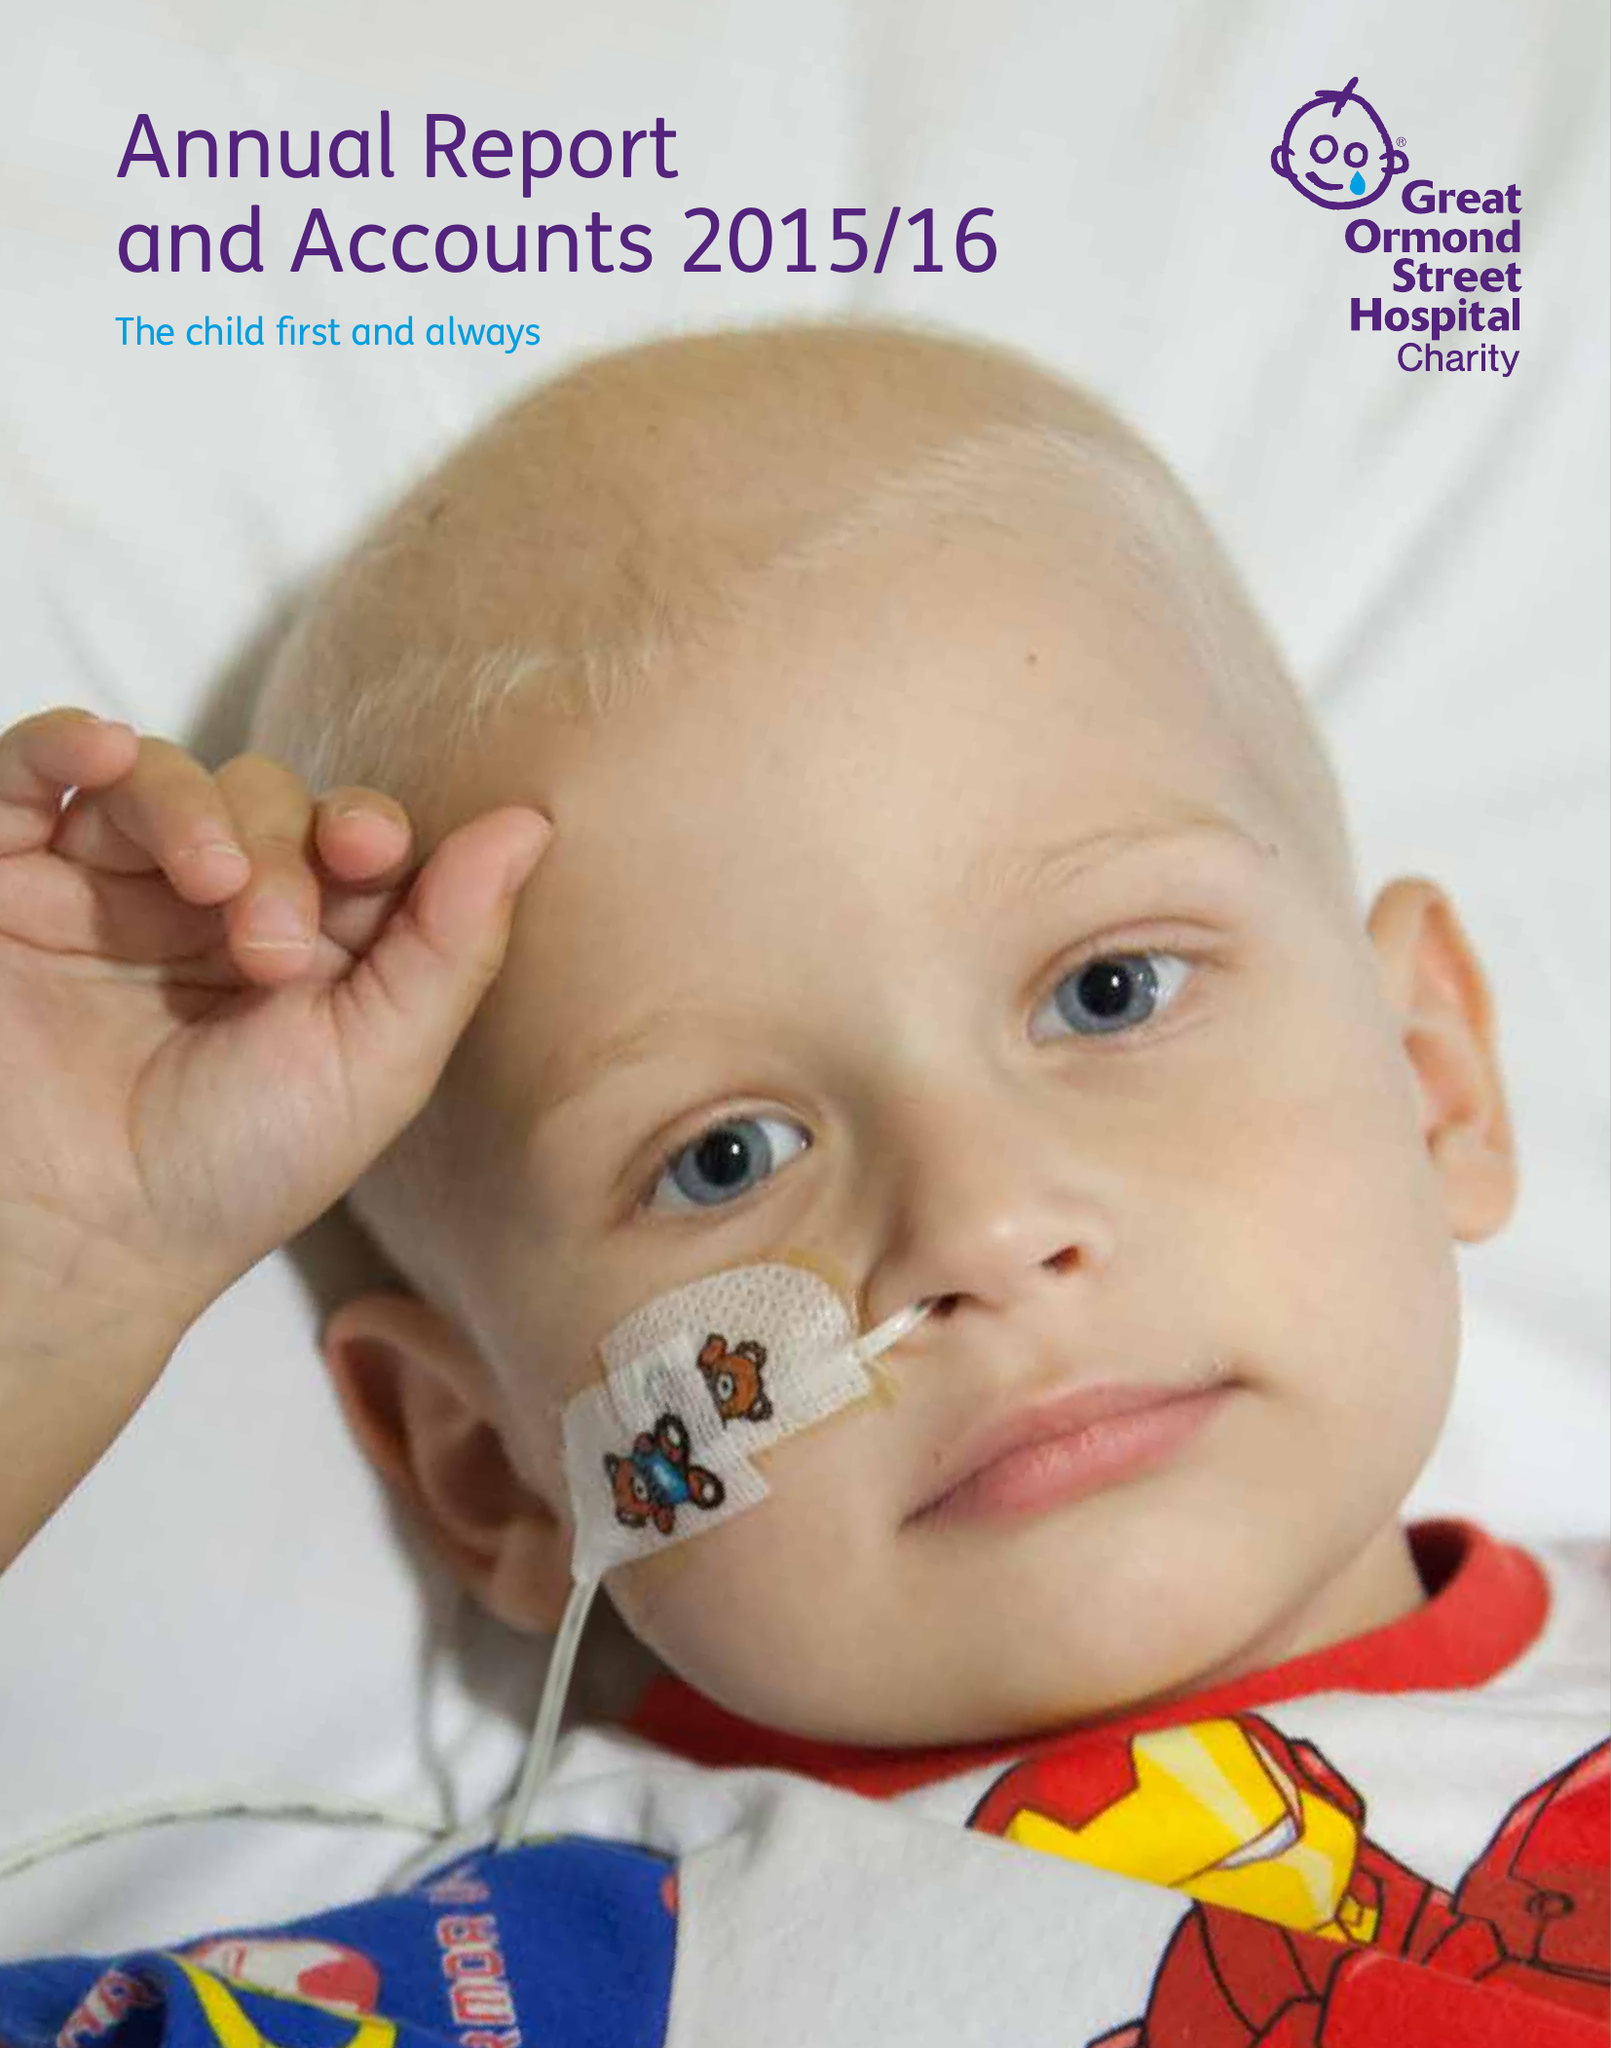What is the value for the income_annually_in_british_pounds?
Answer the question using a single word or phrase. 93777000.00 